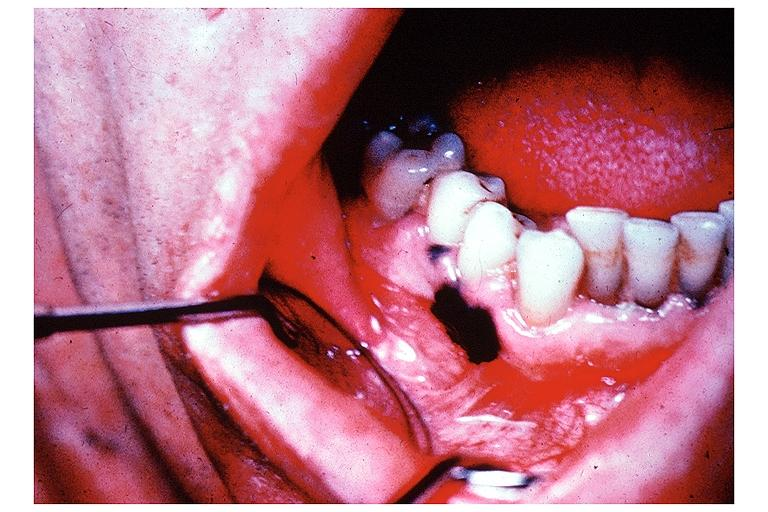what does this image show?
Answer the question using a single word or phrase. Melanoma 